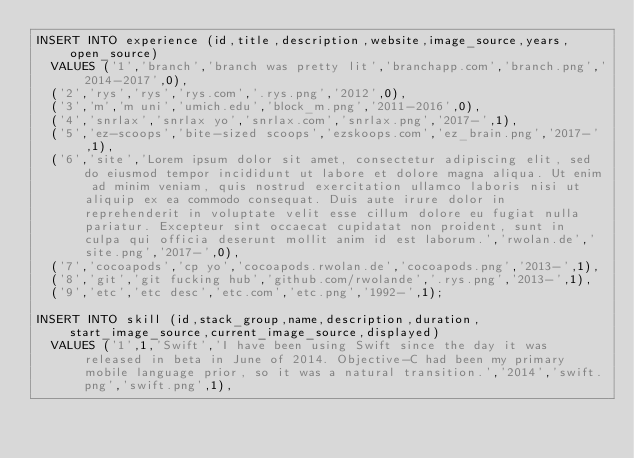<code> <loc_0><loc_0><loc_500><loc_500><_SQL_>INSERT INTO experience (id,title,description,website,image_source,years,open_source)
  VALUES ('1','branch','branch was pretty lit','branchapp.com','branch.png','2014-2017',0),
  ('2','rys','rys','rys.com','.rys.png','2012',0),
  ('3','m','m uni','umich.edu','block_m.png','2011-2016',0),
  ('4','snrlax','snrlax yo','snrlax.com','snrlax.png','2017-',1),
  ('5','ez-scoops','bite-sized scoops','ezskoops.com','ez_brain.png','2017-',1),
  ('6','site','Lorem ipsum dolor sit amet, consectetur adipiscing elit, sed do eiusmod tempor incididunt ut labore et dolore magna aliqua. Ut enim ad minim veniam, quis nostrud exercitation ullamco laboris nisi ut aliquip ex ea commodo consequat. Duis aute irure dolor in reprehenderit in voluptate velit esse cillum dolore eu fugiat nulla pariatur. Excepteur sint occaecat cupidatat non proident, sunt in culpa qui officia deserunt mollit anim id est laborum.','rwolan.de','site.png','2017-',0),
  ('7','cocoapods','cp yo','cocoapods.rwolan.de','cocoapods.png','2013-',1),
  ('8','git','git fucking hub','github.com/rwolande','.rys.png','2013-',1),
  ('9','etc','etc desc','etc.com','etc.png','1992-',1);

INSERT INTO skill (id,stack_group,name,description,duration,start_image_source,current_image_source,displayed)
  VALUES ('1',1,'Swift','I have been using Swift since the day it was released in beta in June of 2014. Objective-C had been my primary mobile language prior, so it was a natural transition.','2014','swift.png','swift.png',1),</code> 